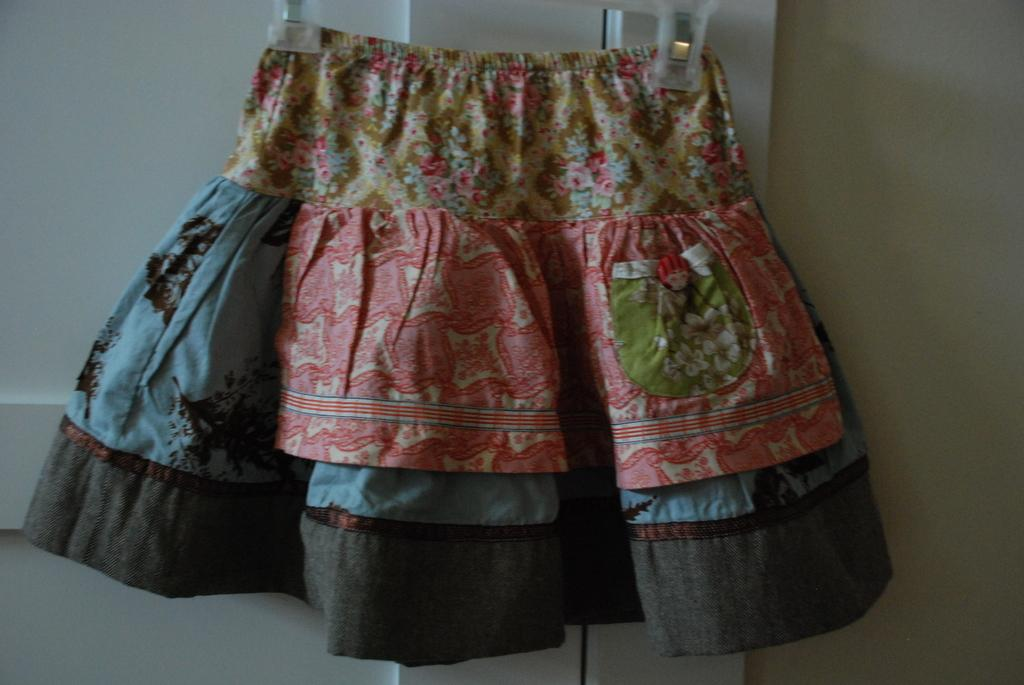What is hanging in front of the door in the image? There is a skirt hanged in front of the door. What can be seen on the right side of the image? There is a wall on the right side of the image. What type of bear can be seen attacking the wall in the image? There is no bear present in the image, nor is there any attack happening on the wall. 